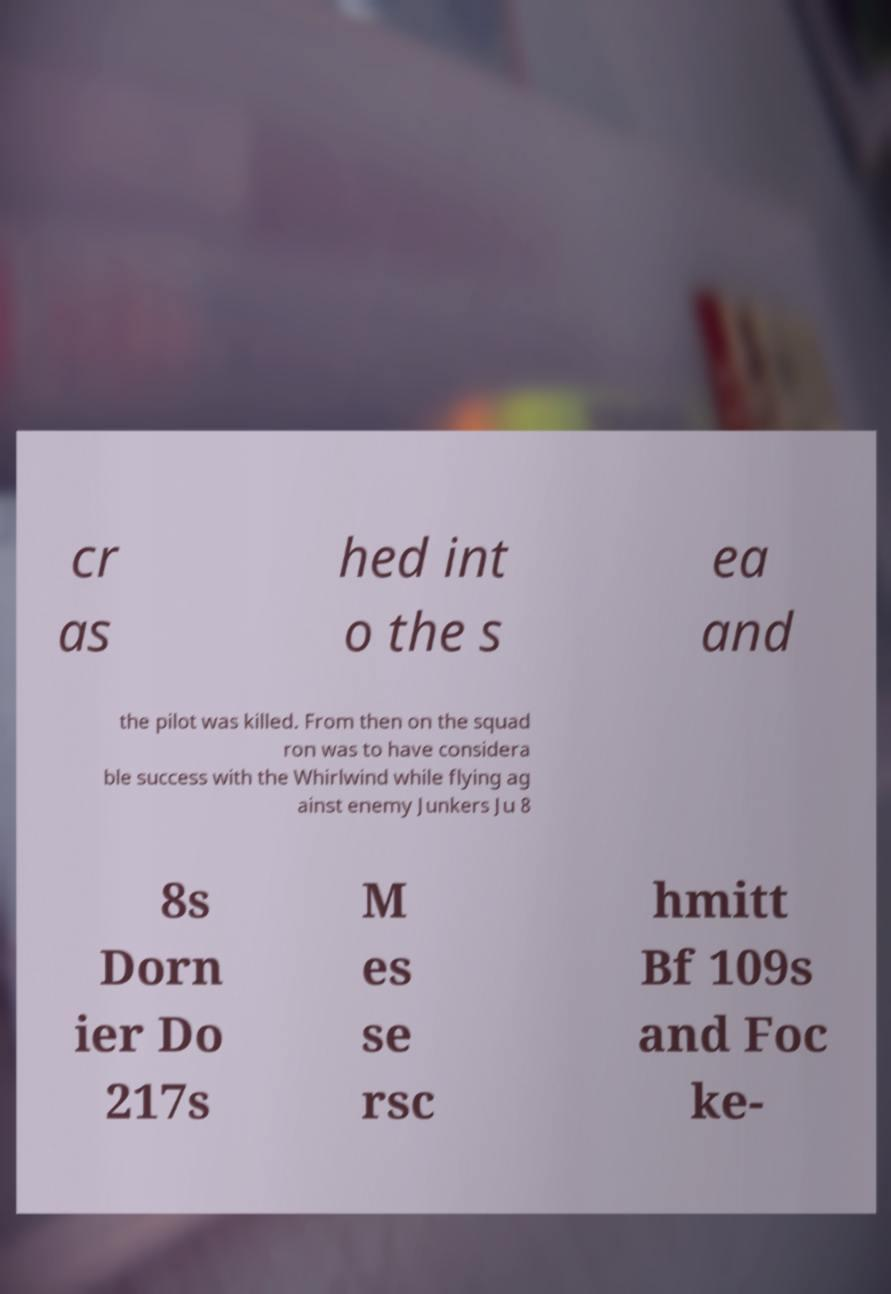Could you extract and type out the text from this image? cr as hed int o the s ea and the pilot was killed. From then on the squad ron was to have considera ble success with the Whirlwind while flying ag ainst enemy Junkers Ju 8 8s Dorn ier Do 217s M es se rsc hmitt Bf 109s and Foc ke- 